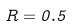<formula> <loc_0><loc_0><loc_500><loc_500>R = 0 . 5</formula> 